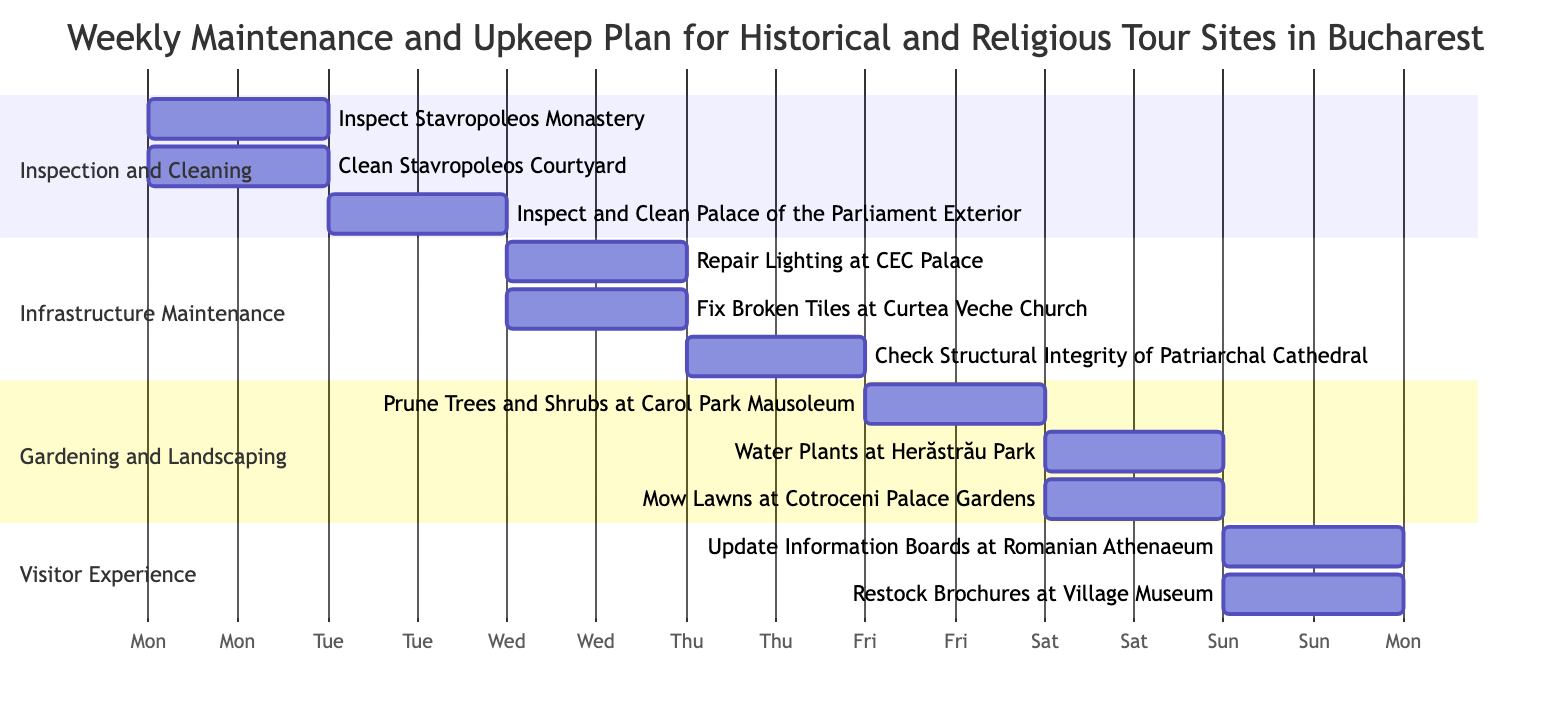What task starts on Tuesday? The task that starts on Tuesday is "Inspect and Clean Palace of the Parliament Exterior". This information is obtained directly from the diagram where the start date for this task is labeled as Tuesday.
Answer: Inspect and Clean Palace of the Parliament Exterior How many tasks are labeled under Gardening and Landscaping? There are three tasks listed under Gardening and Landscaping: "Prune Trees and Shrubs at Carol Park Mausoleum", "Water Plants at Herăstrău Park", and "Mow Lawns at Cotroceni Palace Gardens". This is counted from the section clearly indicating three subtasks.
Answer: 3 What duration does the task "Check Structural Integrity of Patriarchal Cathedral" have? The duration for "Check Structural Integrity of Patriarchal Cathedral" is specified as one day, as indicated next to the task in the diagram.
Answer: 1 day Which task has the longest duration in the Inspection and Cleaning section? The task with the longest duration in the Inspection and Cleaning section is "Inspect and Clean Palace of the Parliament Exterior", which has a duration of one day. This is confirmed by reviewing the durations of the tasks listed under that section.
Answer: Inspect and Clean Palace of the Parliament Exterior What day is dedicated to visitor experience tasks? Sunday is the day dedicated to visitor experience tasks, as both "Update Information Boards at Romanian Athenaeum" and "Restock Brochures at Village Museum" begin on that day. This is seen from the diagram which organizes tasks by their starting days.
Answer: Sunday 